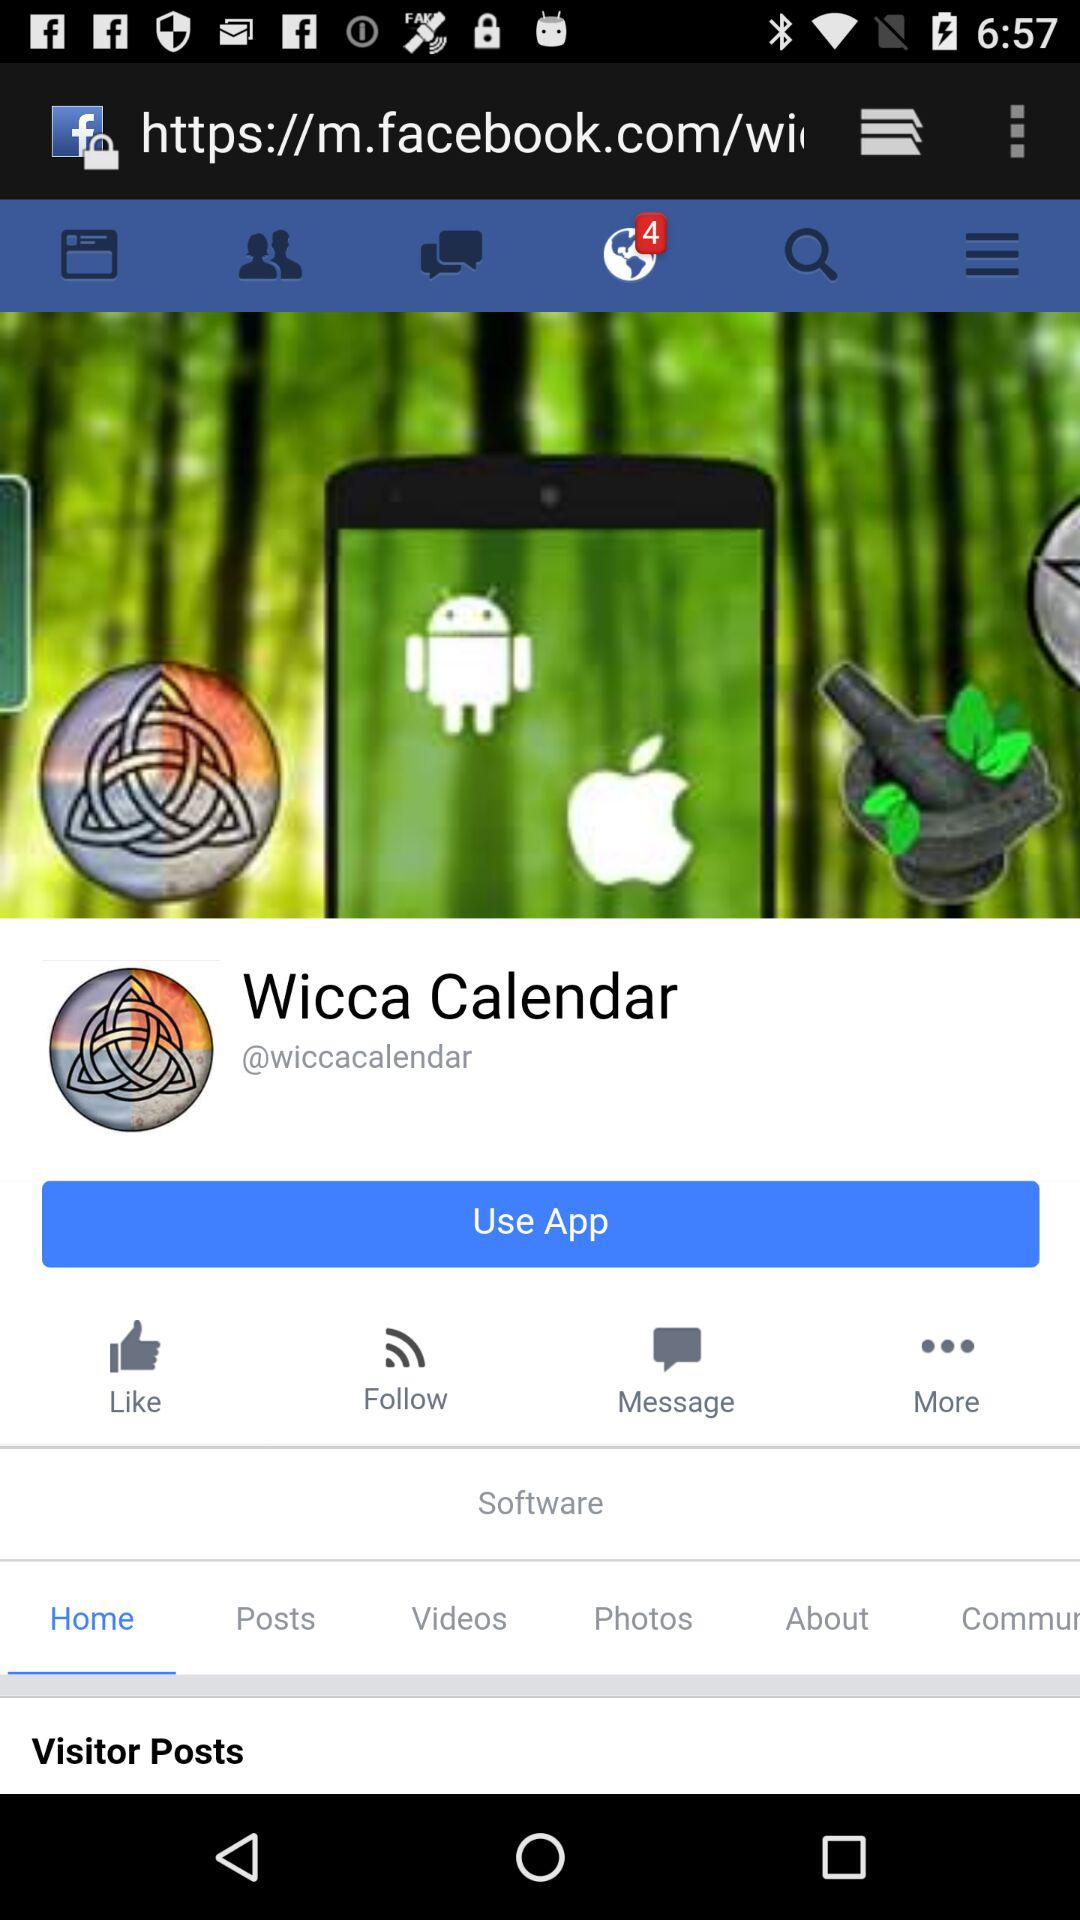How many unread notifications are there? There are four unread notifications. 